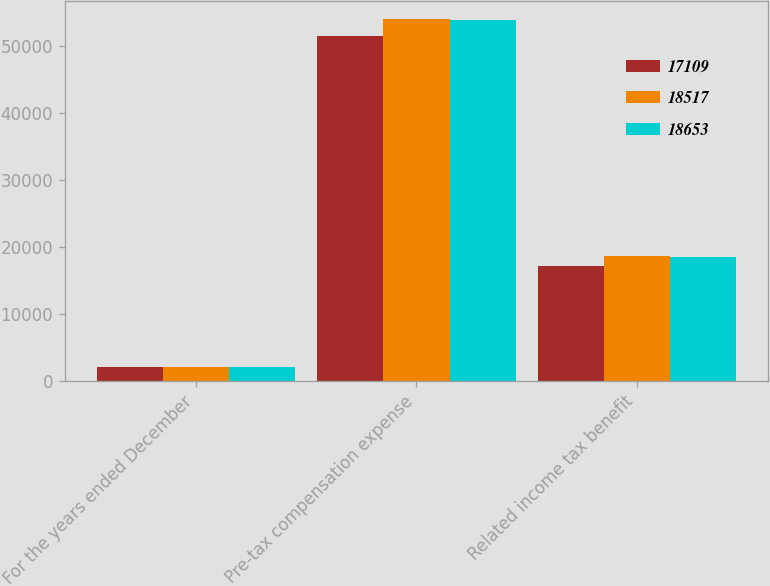Convert chart. <chart><loc_0><loc_0><loc_500><loc_500><stacked_bar_chart><ecel><fcel>For the years ended December<fcel>Pre-tax compensation expense<fcel>Related income tax benefit<nl><fcel>17109<fcel>2015<fcel>51533<fcel>17109<nl><fcel>18517<fcel>2014<fcel>54068<fcel>18653<nl><fcel>18653<fcel>2013<fcel>53984<fcel>18517<nl></chart> 